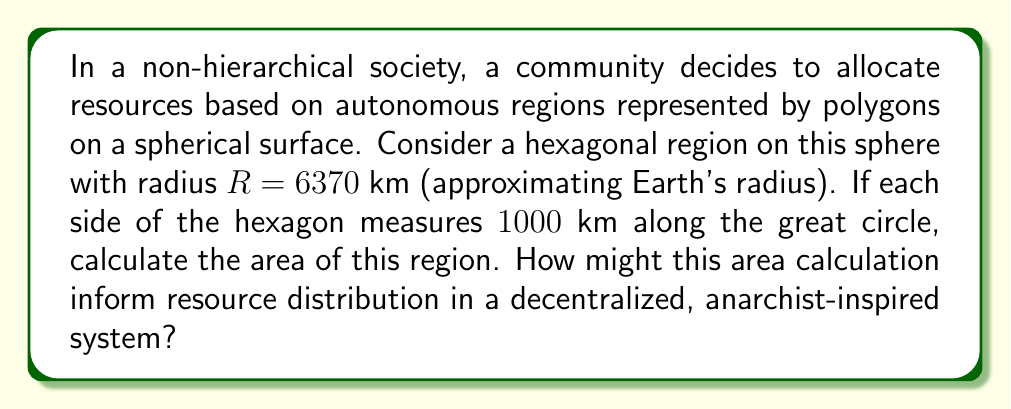Give your solution to this math problem. To solve this problem, we'll use concepts from spherical geometry:

1) First, we need to calculate the angular radius $\theta$ of the hexagon:
   $\theta = \frac{s}{R}$, where $s$ is the side length
   $\theta = \frac{1000 \text{ km}}{6370 \text{ km}} \approx 0.157$ radians

2) The area of a spherical polygon is given by the formula:
   $A = R^2(n\theta - (n-2)\pi)$
   Where $n$ is the number of sides, $\theta$ is the angular radius, and $R$ is the sphere's radius

3) Substituting our values:
   $A = (6370 \text{ km})^2(6 \cdot 0.157 - (6-2)\pi)$
   $A = 40576900 \text{ km}^2(0.942 - 4\pi)$
   $A = 40576900 \text{ km}^2(-11.621)$
   $A \approx 471,547,865 \text{ km}^2$

4) This area represents about 92.5% of Earth's surface area, which is unrealistically large for a local community. This highlights the importance of scale in non-hierarchical systems and the need for careful consideration of territorial divisions.

5) In an anarchist-inspired system, this calculation could inform:
   - Equitable resource allocation based on population density
   - Decentralized decision-making processes within the region
   - Collaborative management of shared resources across adjacent regions
   - Flexible boundaries that adapt to changing community needs
Answer: $471,547,865 \text{ km}^2$ 